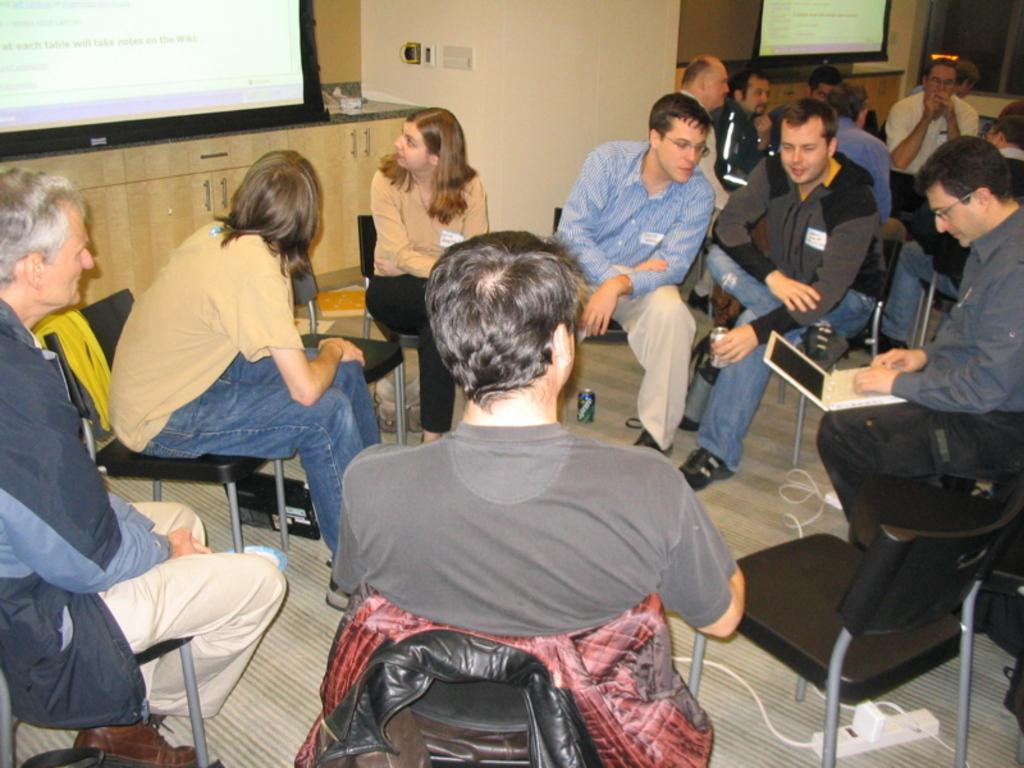How many people are in the group that is visible in the image? There is a group of people in the image. What are some of the people in the group doing? Some people in the group are sitting, while others are watching a screen and operating a laptop. Can you describe the activities of the people in the group? The people in the group are engaged in various activities, such as sitting, watching a screen, and operating a laptop. How many sisters are present in the image? There is no mention of sisters in the image, so it is not possible to determine their presence. 